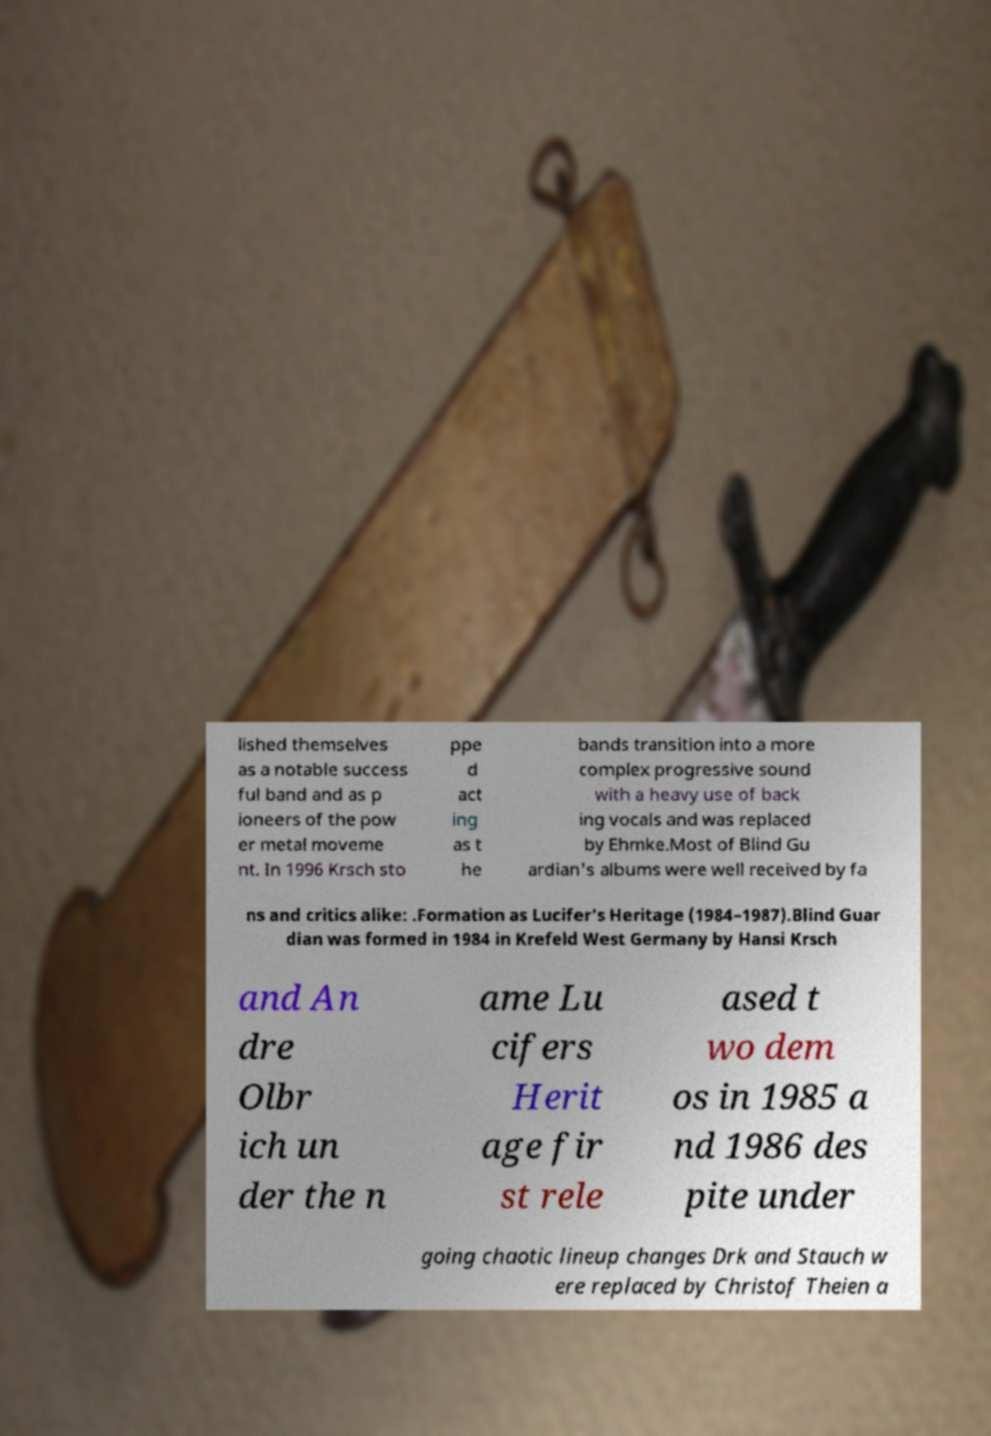Please identify and transcribe the text found in this image. lished themselves as a notable success ful band and as p ioneers of the pow er metal moveme nt. In 1996 Krsch sto ppe d act ing as t he bands transition into a more complex progressive sound with a heavy use of back ing vocals and was replaced by Ehmke.Most of Blind Gu ardian's albums were well received by fa ns and critics alike: .Formation as Lucifer's Heritage (1984–1987).Blind Guar dian was formed in 1984 in Krefeld West Germany by Hansi Krsch and An dre Olbr ich un der the n ame Lu cifers Herit age fir st rele ased t wo dem os in 1985 a nd 1986 des pite under going chaotic lineup changes Drk and Stauch w ere replaced by Christof Theien a 